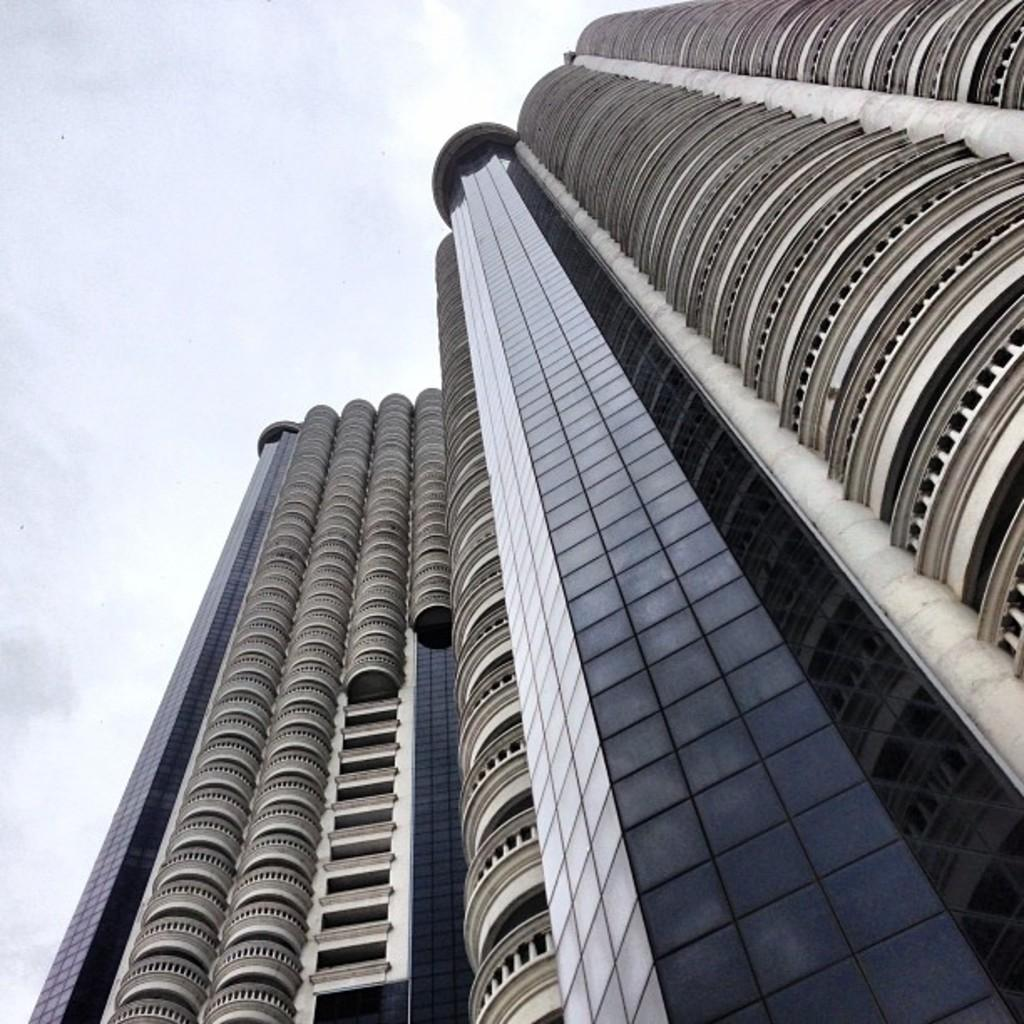What is the main subject of the image? The main subject of the image is a skyscraper. Where is the skyscraper located in the image? The skyscraper is in the center of the image. What can be observed about the skyscraper's appearance? The skyscraper has many glass windows. Can you see a girl running with a glass of juice in the image? No, there is no girl running with a glass of juice in the image. The image only features a skyscraper with many glass windows. 